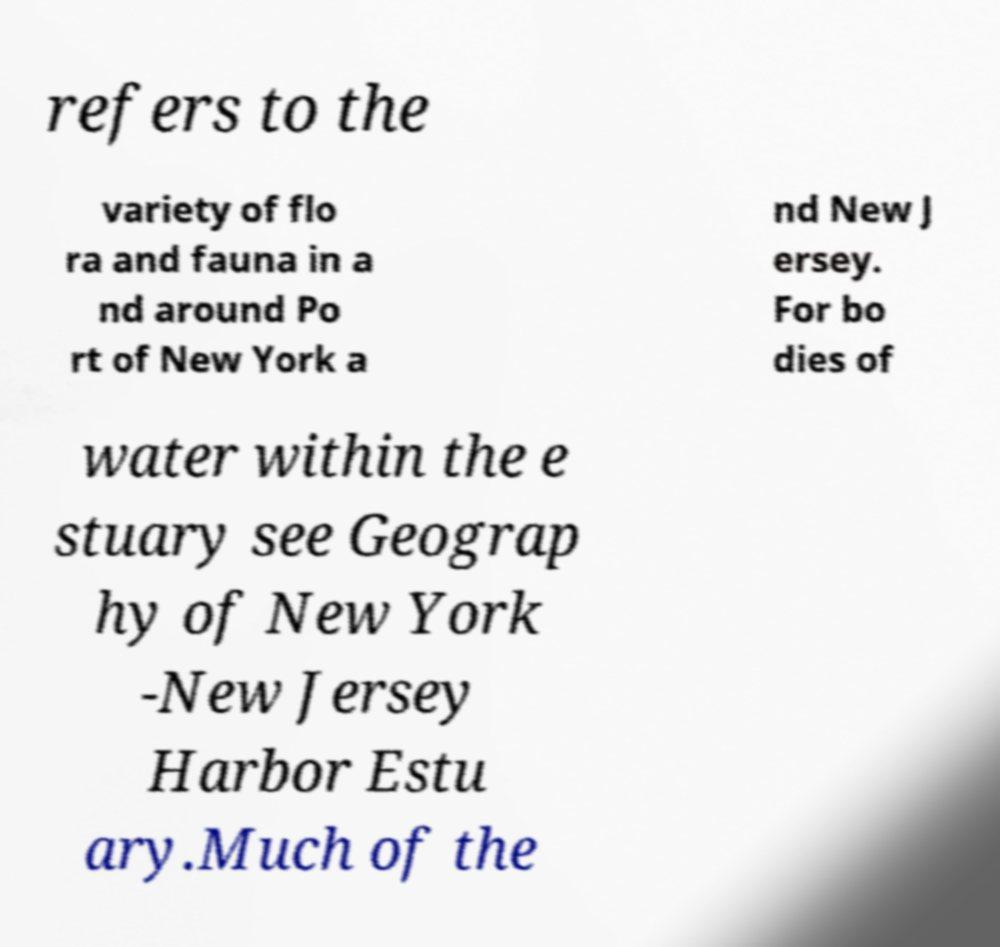Please identify and transcribe the text found in this image. refers to the variety of flo ra and fauna in a nd around Po rt of New York a nd New J ersey. For bo dies of water within the e stuary see Geograp hy of New York -New Jersey Harbor Estu ary.Much of the 